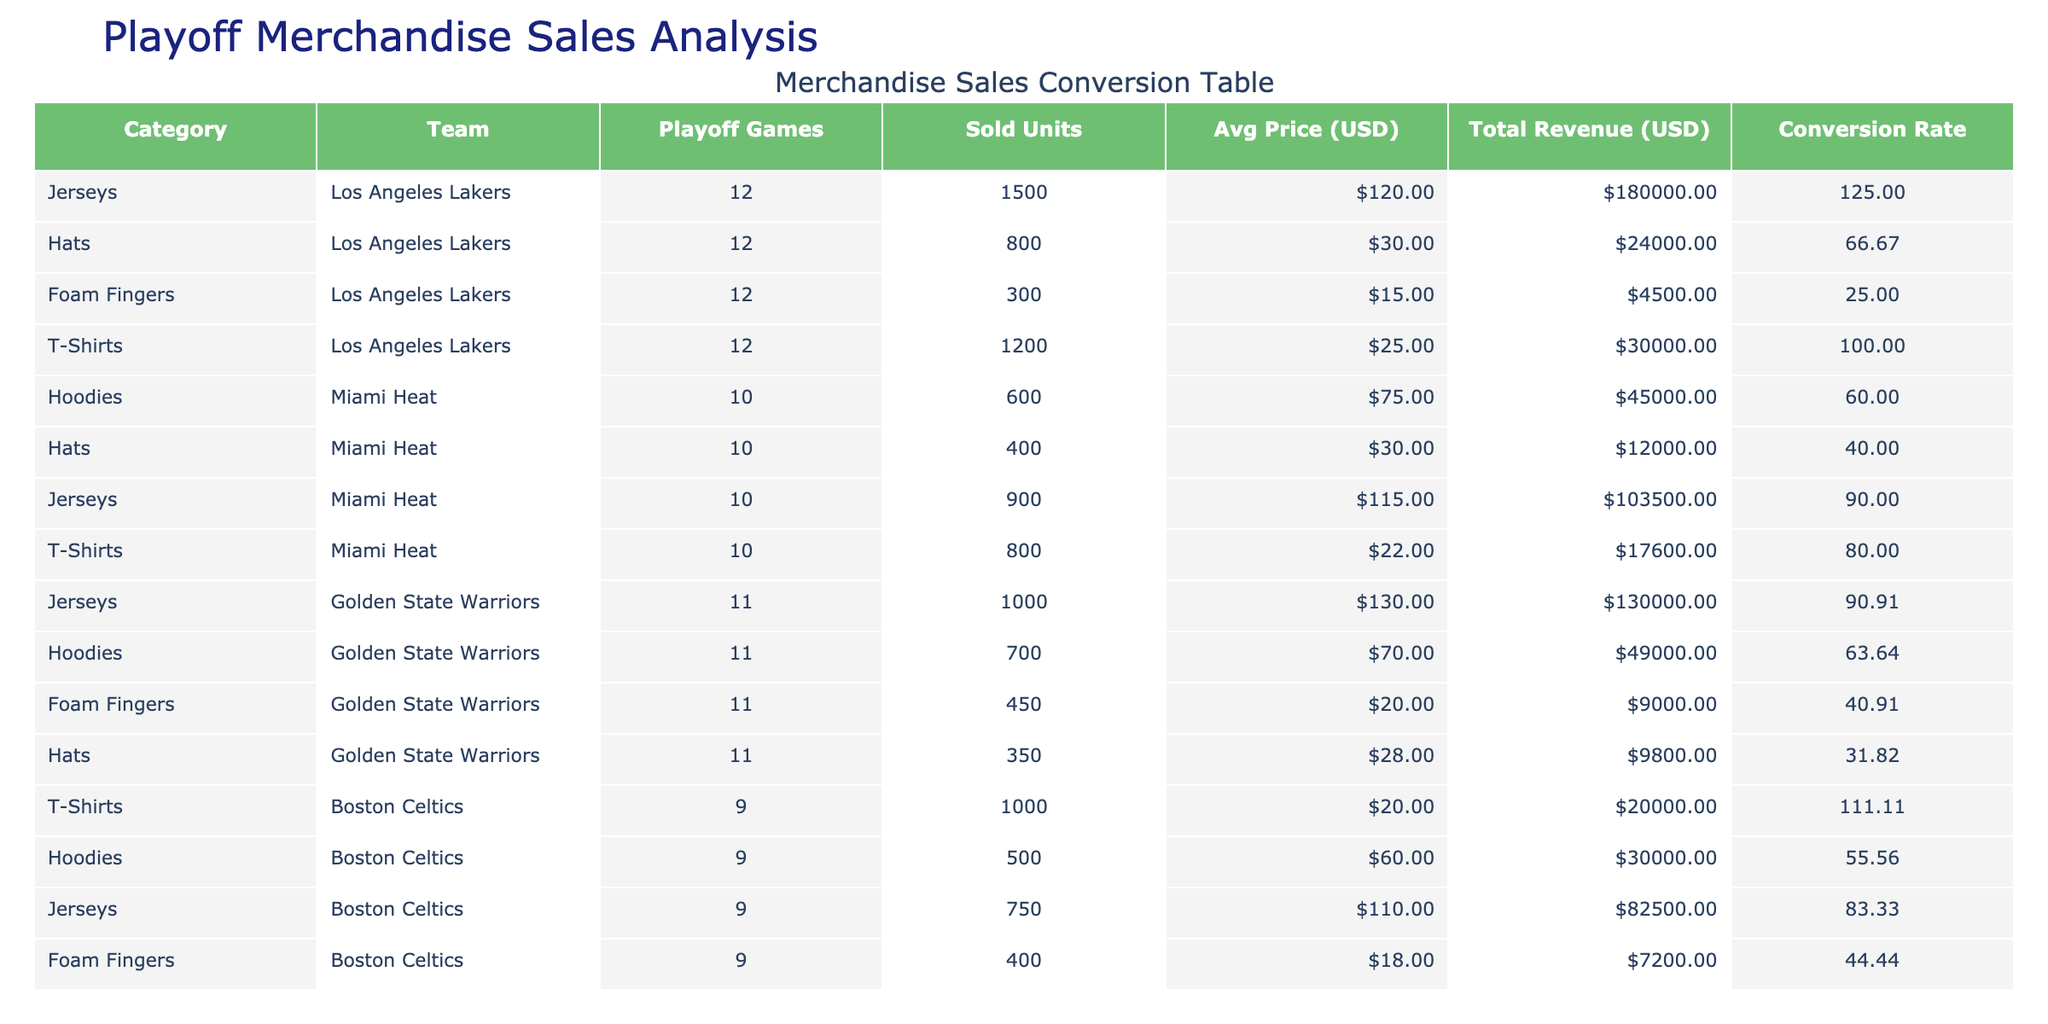What is the total revenue generated by the Miami Heat for jerseys? The total revenue for each category is listed under the "Total Revenue (USD)" column. For the Miami Heat, their jersey sales generated a total revenue of 103500 USD.
Answer: 103500 USD Which team sold the highest number of foam fingers? Looking at the "Sold Units" column for foam fingers, the Los Angeles Lakers sold 300 units, the Miami Heat did not sell any foam fingers, and the Golden State Warriors sold 450 units. Therefore, the Golden State Warriors had the highest sales for foam fingers.
Answer: Golden State Warriors What is the average price per unit for T-shirts sold by the Boston Celtics? The average price per unit for T-shirts sold by the Boston Celtics is mentioned in the "Average Price per Unit (USD)" column. The value for the Boston Celtics is 20 USD.
Answer: 20 USD How many total units of merchandise were sold by the Golden State Warriors? To find the total units sold, sum the "Sold Units" for each category of the Golden State Warriors: 1000 (jerseys) + 700 (hoodies) + 450 (foam fingers) + 350 (hats) = 2500.
Answer: 2500 Did the Miami Heat generate more revenue from T-shirts than from hats? The total revenue from T-shirts is 17600 USD, and from hats is 12000 USD, indicating that the Miami Heat made more from T-shirts.
Answer: Yes What is the conversion rate for sold units per playoff game for the Los Angeles Lakers? The conversion rate is calculated by dividing the total units sold by the playoff games played. For the Lakers, it's 1500 sold units divided by 12 playoff games, which equals 125.
Answer: 125 Which team had the higher average price per unit for hoodies, and what is the difference in the prices? The Los Angeles Lakers average price per unit for hoodies is not present, so we use Miami Heat's price of 75 USD and Golden State Warriors' price of 70 USD. Therefore, Miami Heat had a higher price, and the difference is 75 - 70 = 5 USD.
Answer: Miami Heat, 5 USD What is the average sold units of merchandise across all teams for hats? The sum of sold units for hats is 800 (Lakers) + 400 (Heat) + 350 (Warriors) = 1550. There are 3 teams, so the average is 1550/3 which equals approximately 516.67.
Answer: 516.67 